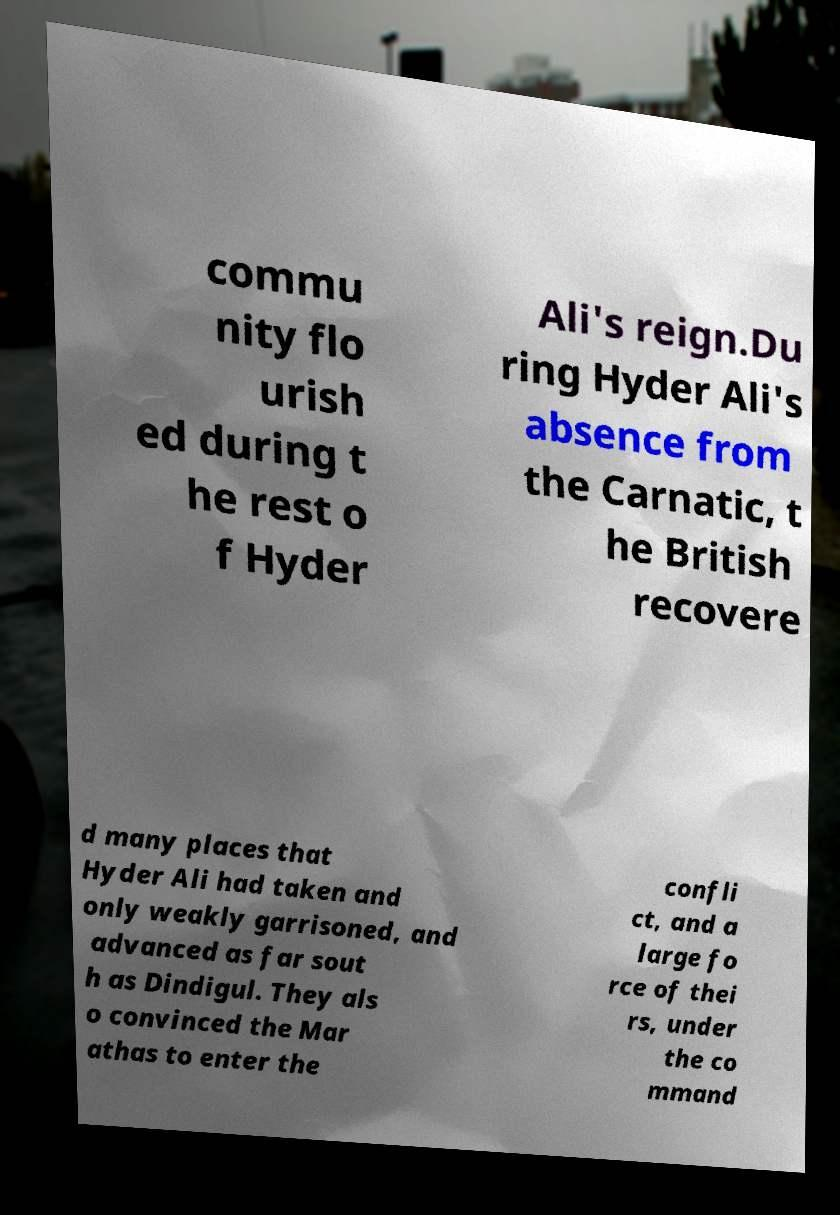Please read and relay the text visible in this image. What does it say? commu nity flo urish ed during t he rest o f Hyder Ali's reign.Du ring Hyder Ali's absence from the Carnatic, t he British recovere d many places that Hyder Ali had taken and only weakly garrisoned, and advanced as far sout h as Dindigul. They als o convinced the Mar athas to enter the confli ct, and a large fo rce of thei rs, under the co mmand 